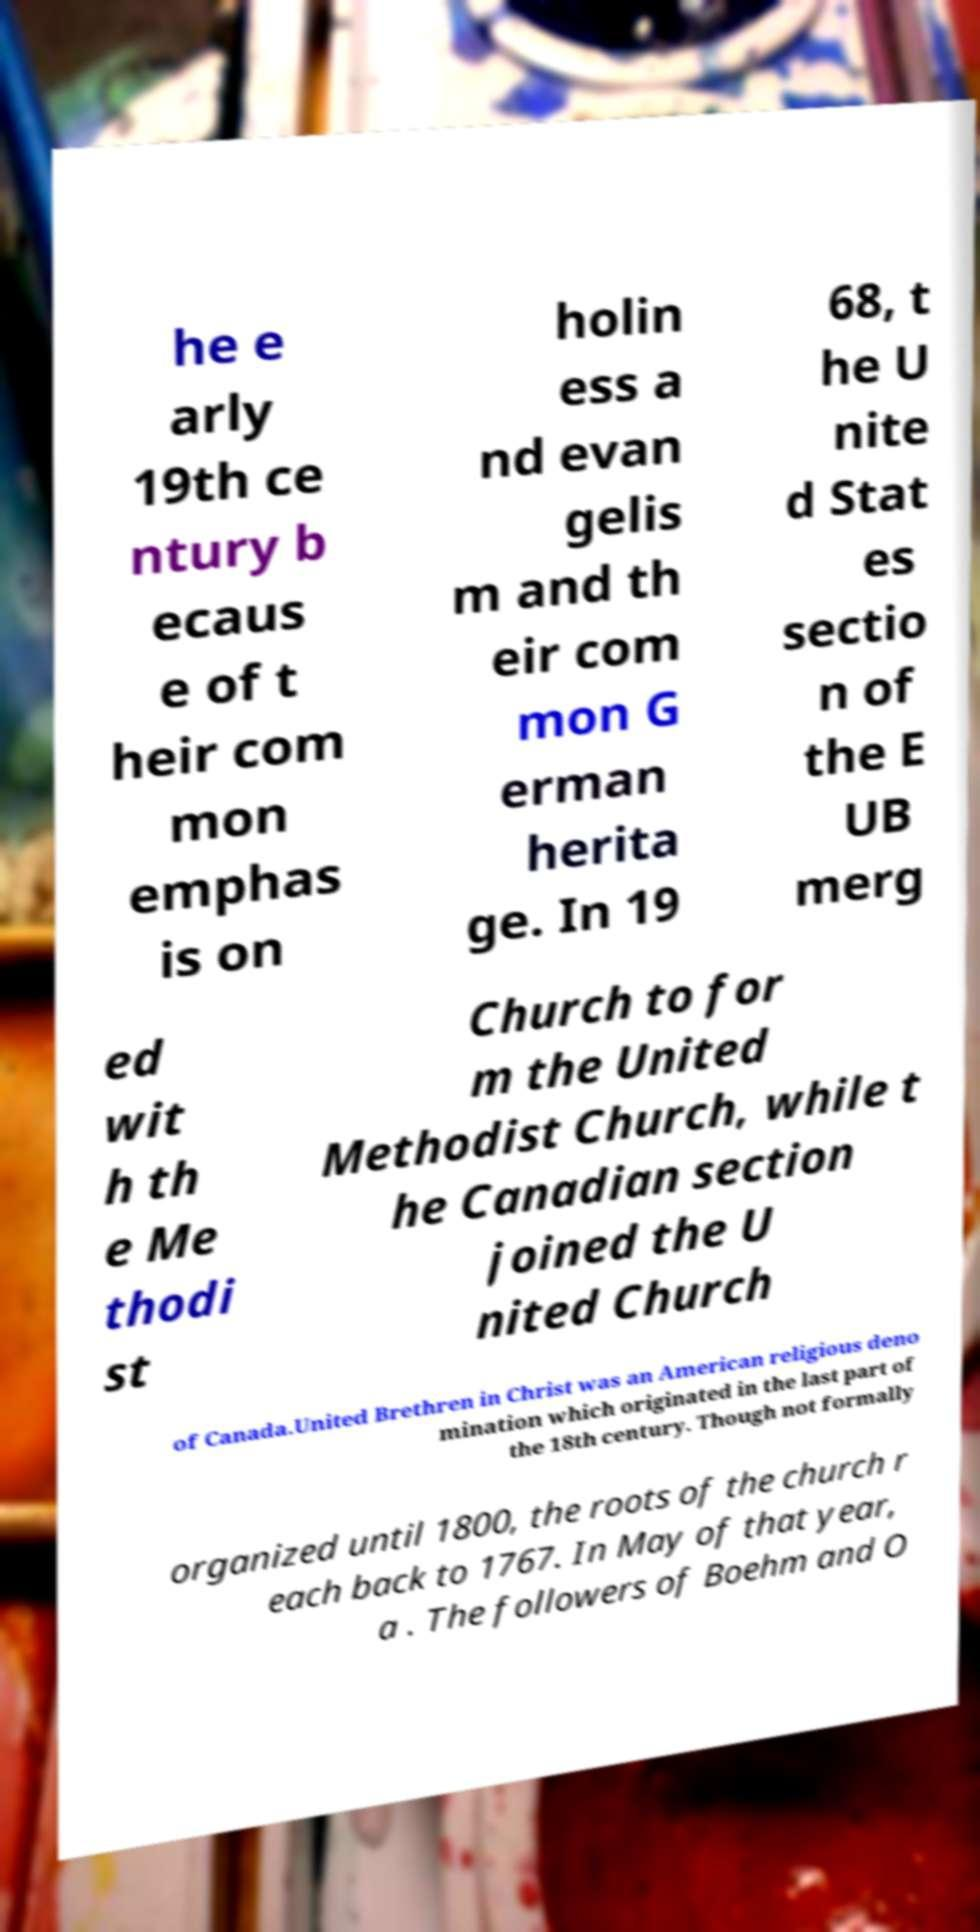What messages or text are displayed in this image? I need them in a readable, typed format. he e arly 19th ce ntury b ecaus e of t heir com mon emphas is on holin ess a nd evan gelis m and th eir com mon G erman herita ge. In 19 68, t he U nite d Stat es sectio n of the E UB merg ed wit h th e Me thodi st Church to for m the United Methodist Church, while t he Canadian section joined the U nited Church of Canada.United Brethren in Christ was an American religious deno mination which originated in the last part of the 18th century. Though not formally organized until 1800, the roots of the church r each back to 1767. In May of that year, a . The followers of Boehm and O 